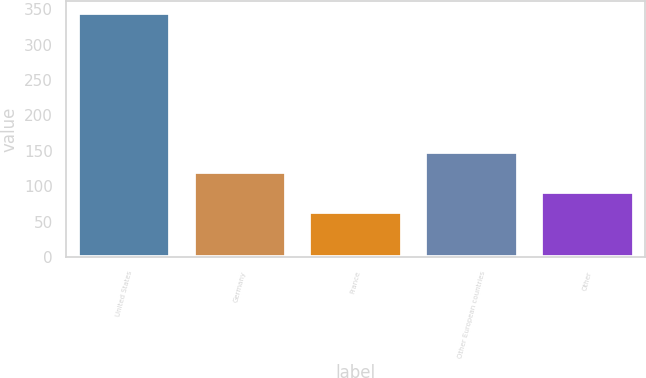Convert chart to OTSL. <chart><loc_0><loc_0><loc_500><loc_500><bar_chart><fcel>United States<fcel>Germany<fcel>France<fcel>Other European countries<fcel>Other<nl><fcel>344.5<fcel>119.7<fcel>63.5<fcel>147.8<fcel>91.6<nl></chart> 